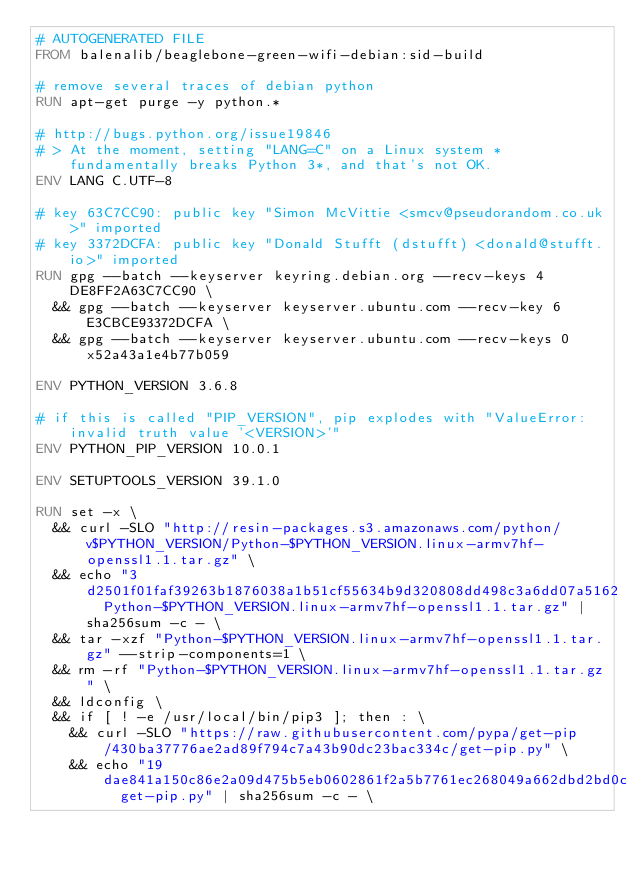Convert code to text. <code><loc_0><loc_0><loc_500><loc_500><_Dockerfile_># AUTOGENERATED FILE
FROM balenalib/beaglebone-green-wifi-debian:sid-build

# remove several traces of debian python
RUN apt-get purge -y python.*

# http://bugs.python.org/issue19846
# > At the moment, setting "LANG=C" on a Linux system *fundamentally breaks Python 3*, and that's not OK.
ENV LANG C.UTF-8

# key 63C7CC90: public key "Simon McVittie <smcv@pseudorandom.co.uk>" imported
# key 3372DCFA: public key "Donald Stufft (dstufft) <donald@stufft.io>" imported
RUN gpg --batch --keyserver keyring.debian.org --recv-keys 4DE8FF2A63C7CC90 \
	&& gpg --batch --keyserver keyserver.ubuntu.com --recv-key 6E3CBCE93372DCFA \
	&& gpg --batch --keyserver keyserver.ubuntu.com --recv-keys 0x52a43a1e4b77b059

ENV PYTHON_VERSION 3.6.8

# if this is called "PIP_VERSION", pip explodes with "ValueError: invalid truth value '<VERSION>'"
ENV PYTHON_PIP_VERSION 10.0.1

ENV SETUPTOOLS_VERSION 39.1.0

RUN set -x \
	&& curl -SLO "http://resin-packages.s3.amazonaws.com/python/v$PYTHON_VERSION/Python-$PYTHON_VERSION.linux-armv7hf-openssl1.1.tar.gz" \
	&& echo "3d2501f01faf39263b1876038a1b51cf55634b9d320808dd498c3a6dd07a5162  Python-$PYTHON_VERSION.linux-armv7hf-openssl1.1.tar.gz" | sha256sum -c - \
	&& tar -xzf "Python-$PYTHON_VERSION.linux-armv7hf-openssl1.1.tar.gz" --strip-components=1 \
	&& rm -rf "Python-$PYTHON_VERSION.linux-armv7hf-openssl1.1.tar.gz" \
	&& ldconfig \
	&& if [ ! -e /usr/local/bin/pip3 ]; then : \
		&& curl -SLO "https://raw.githubusercontent.com/pypa/get-pip/430ba37776ae2ad89f794c7a43b90dc23bac334c/get-pip.py" \
		&& echo "19dae841a150c86e2a09d475b5eb0602861f2a5b7761ec268049a662dbd2bd0c  get-pip.py" | sha256sum -c - \</code> 